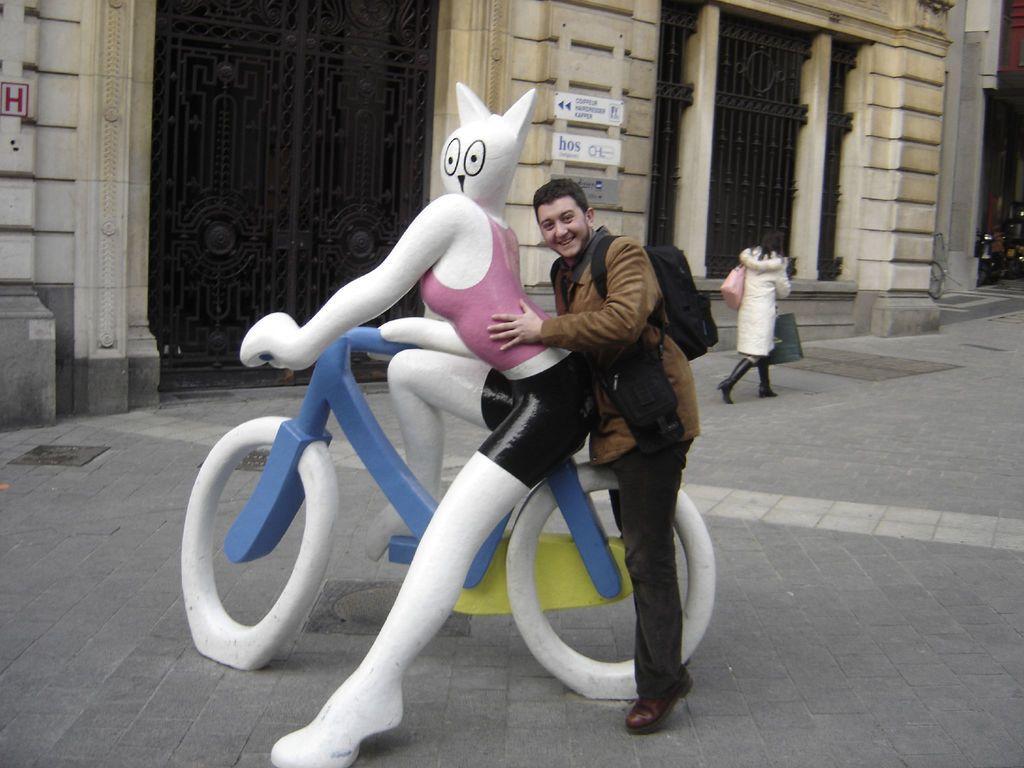How would you summarize this image in a sentence or two? In the picture we can see a doll of a woman riding artificial bicycle placed on the path and behind it we can see a man is sitting and smiling and behind him we can see a building wall with two black color gates to it and near it we can see a woman walking with some bags. 